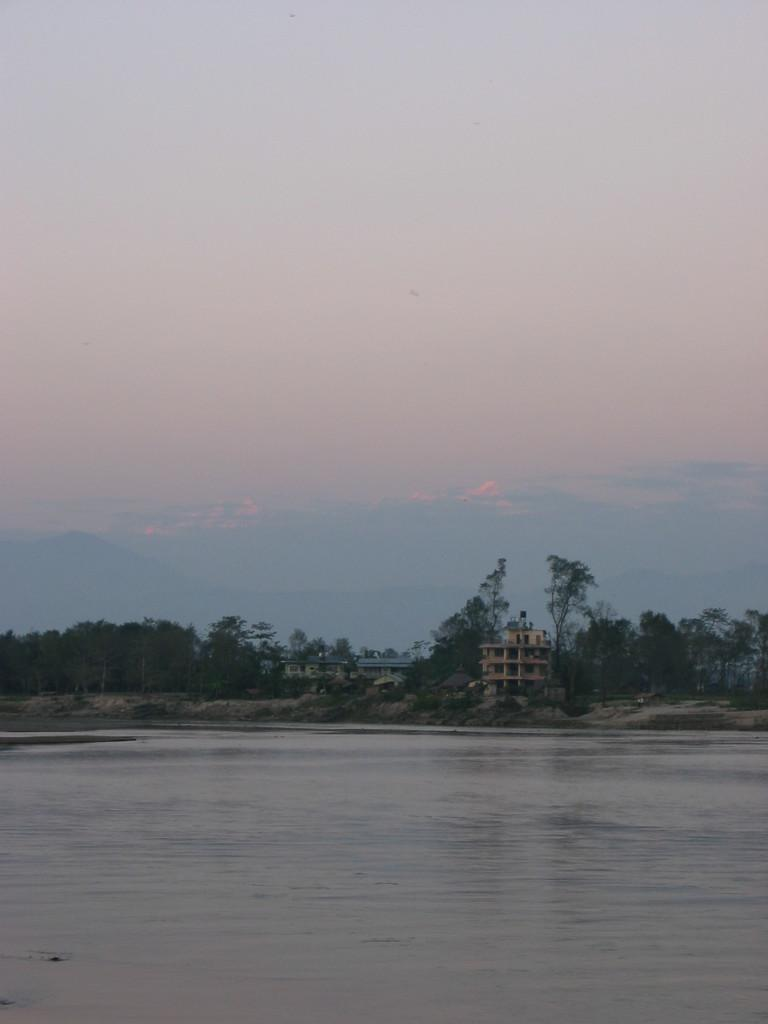What is the primary element visible in the image? There is water in the image. What can be seen in the distance behind the water? There are buildings and trees in the background of the image. What is the condition of the sky in the image? The sky is clear and visible at the top of the image. How many boys are playing in the water in the image? There are no boys present in the image; it only features water, buildings, trees, and a clear sky. 